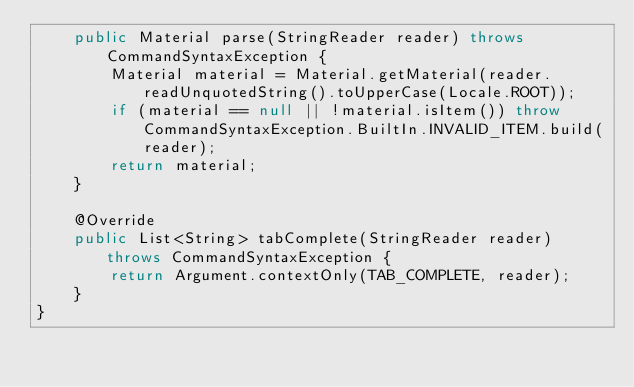Convert code to text. <code><loc_0><loc_0><loc_500><loc_500><_Java_>    public Material parse(StringReader reader) throws CommandSyntaxException {
        Material material = Material.getMaterial(reader.readUnquotedString().toUpperCase(Locale.ROOT));
        if (material == null || !material.isItem()) throw CommandSyntaxException.BuiltIn.INVALID_ITEM.build(reader);
        return material;
    }

    @Override
    public List<String> tabComplete(StringReader reader) throws CommandSyntaxException {
        return Argument.contextOnly(TAB_COMPLETE, reader);
    }
}
</code> 